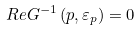<formula> <loc_0><loc_0><loc_500><loc_500>R e G ^ { - 1 } \left ( p , \varepsilon _ { p } \right ) = 0</formula> 